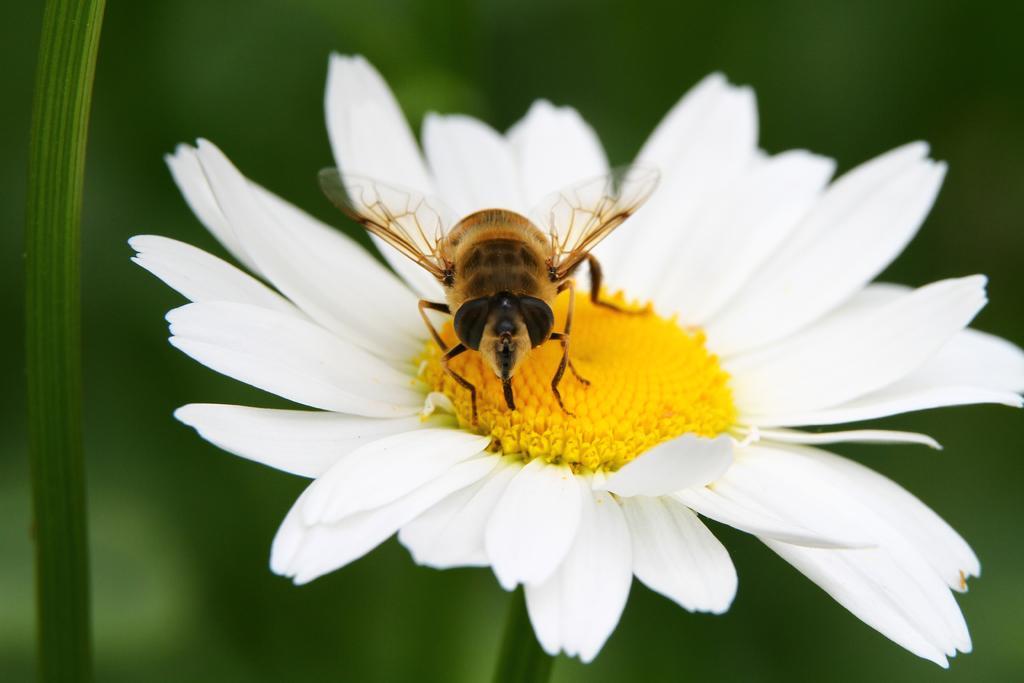Can you describe this image briefly? In the foreground of this image, there is a honey bee on a white flower and the green background. 